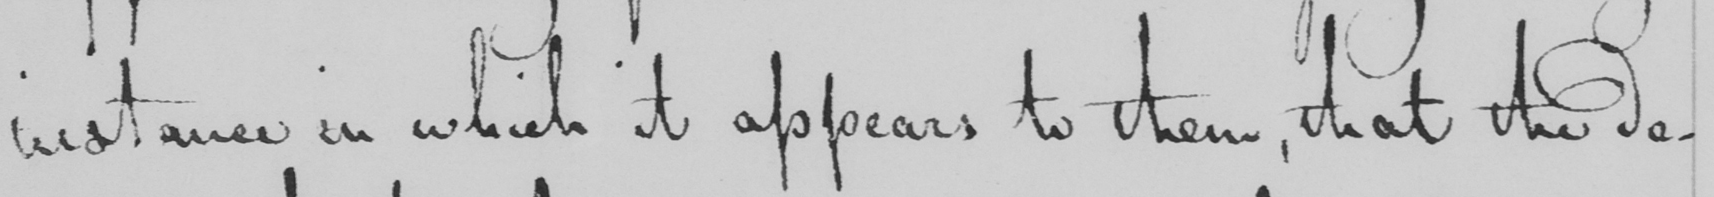What text is written in this handwritten line? instance in which it appears to them , that the de- 